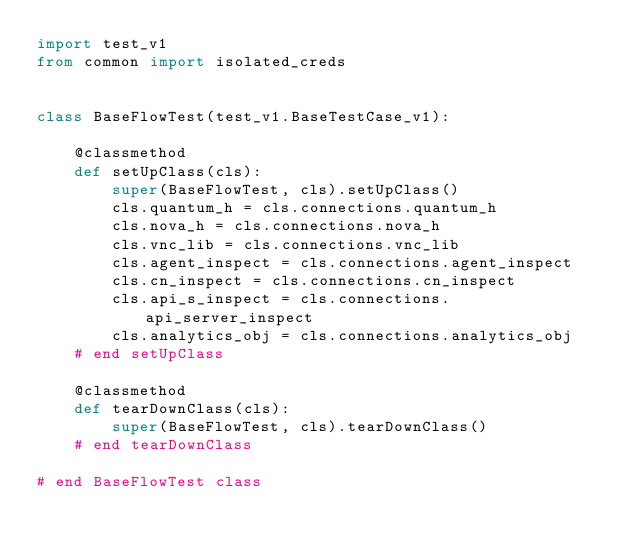Convert code to text. <code><loc_0><loc_0><loc_500><loc_500><_Python_>import test_v1
from common import isolated_creds


class BaseFlowTest(test_v1.BaseTestCase_v1):

    @classmethod
    def setUpClass(cls):
        super(BaseFlowTest, cls).setUpClass()
        cls.quantum_h = cls.connections.quantum_h
        cls.nova_h = cls.connections.nova_h
        cls.vnc_lib = cls.connections.vnc_lib
        cls.agent_inspect = cls.connections.agent_inspect
        cls.cn_inspect = cls.connections.cn_inspect
        cls.api_s_inspect = cls.connections.api_server_inspect
        cls.analytics_obj = cls.connections.analytics_obj
    # end setUpClass

    @classmethod
    def tearDownClass(cls):
        super(BaseFlowTest, cls).tearDownClass()
    # end tearDownClass

# end BaseFlowTest class
</code> 